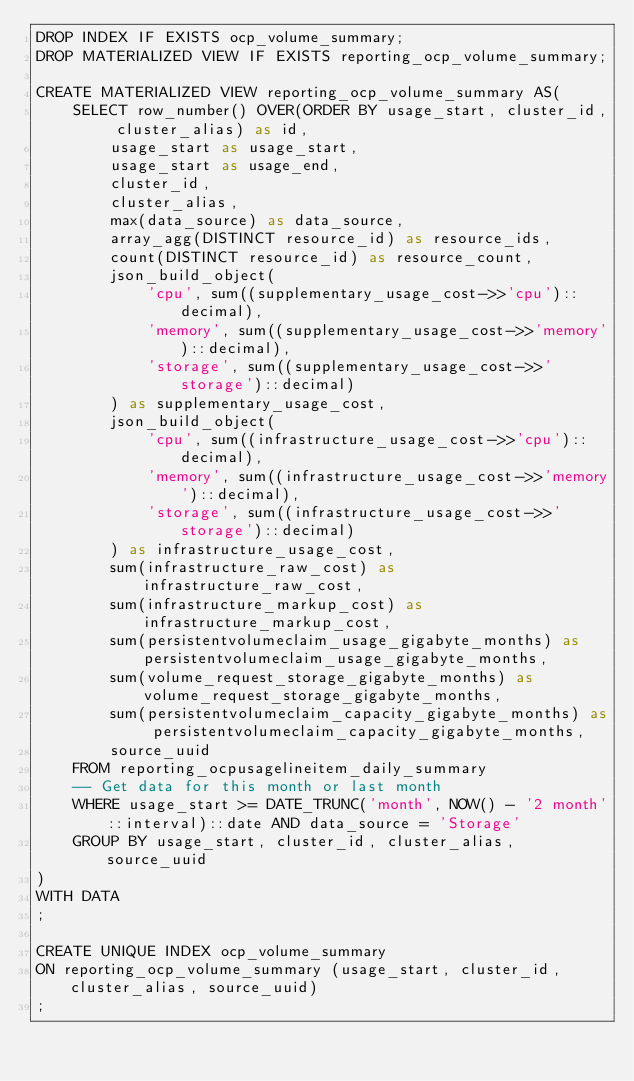Convert code to text. <code><loc_0><loc_0><loc_500><loc_500><_SQL_>DROP INDEX IF EXISTS ocp_volume_summary;
DROP MATERIALIZED VIEW IF EXISTS reporting_ocp_volume_summary;

CREATE MATERIALIZED VIEW reporting_ocp_volume_summary AS(
    SELECT row_number() OVER(ORDER BY usage_start, cluster_id, cluster_alias) as id,
        usage_start as usage_start,
        usage_start as usage_end,
        cluster_id,
        cluster_alias,
        max(data_source) as data_source,
        array_agg(DISTINCT resource_id) as resource_ids,
        count(DISTINCT resource_id) as resource_count,
        json_build_object(
            'cpu', sum((supplementary_usage_cost->>'cpu')::decimal),
            'memory', sum((supplementary_usage_cost->>'memory')::decimal),
            'storage', sum((supplementary_usage_cost->>'storage')::decimal)
        ) as supplementary_usage_cost,
        json_build_object(
            'cpu', sum((infrastructure_usage_cost->>'cpu')::decimal),
            'memory', sum((infrastructure_usage_cost->>'memory')::decimal),
            'storage', sum((infrastructure_usage_cost->>'storage')::decimal)
        ) as infrastructure_usage_cost,
        sum(infrastructure_raw_cost) as infrastructure_raw_cost,
        sum(infrastructure_markup_cost) as infrastructure_markup_cost,
        sum(persistentvolumeclaim_usage_gigabyte_months) as persistentvolumeclaim_usage_gigabyte_months,
        sum(volume_request_storage_gigabyte_months) as volume_request_storage_gigabyte_months,
        sum(persistentvolumeclaim_capacity_gigabyte_months) as persistentvolumeclaim_capacity_gigabyte_months,
        source_uuid
    FROM reporting_ocpusagelineitem_daily_summary
    -- Get data for this month or last month
    WHERE usage_start >= DATE_TRUNC('month', NOW() - '2 month'::interval)::date AND data_source = 'Storage'
    GROUP BY usage_start, cluster_id, cluster_alias, source_uuid
)
WITH DATA
;

CREATE UNIQUE INDEX ocp_volume_summary
ON reporting_ocp_volume_summary (usage_start, cluster_id, cluster_alias, source_uuid)
;
</code> 